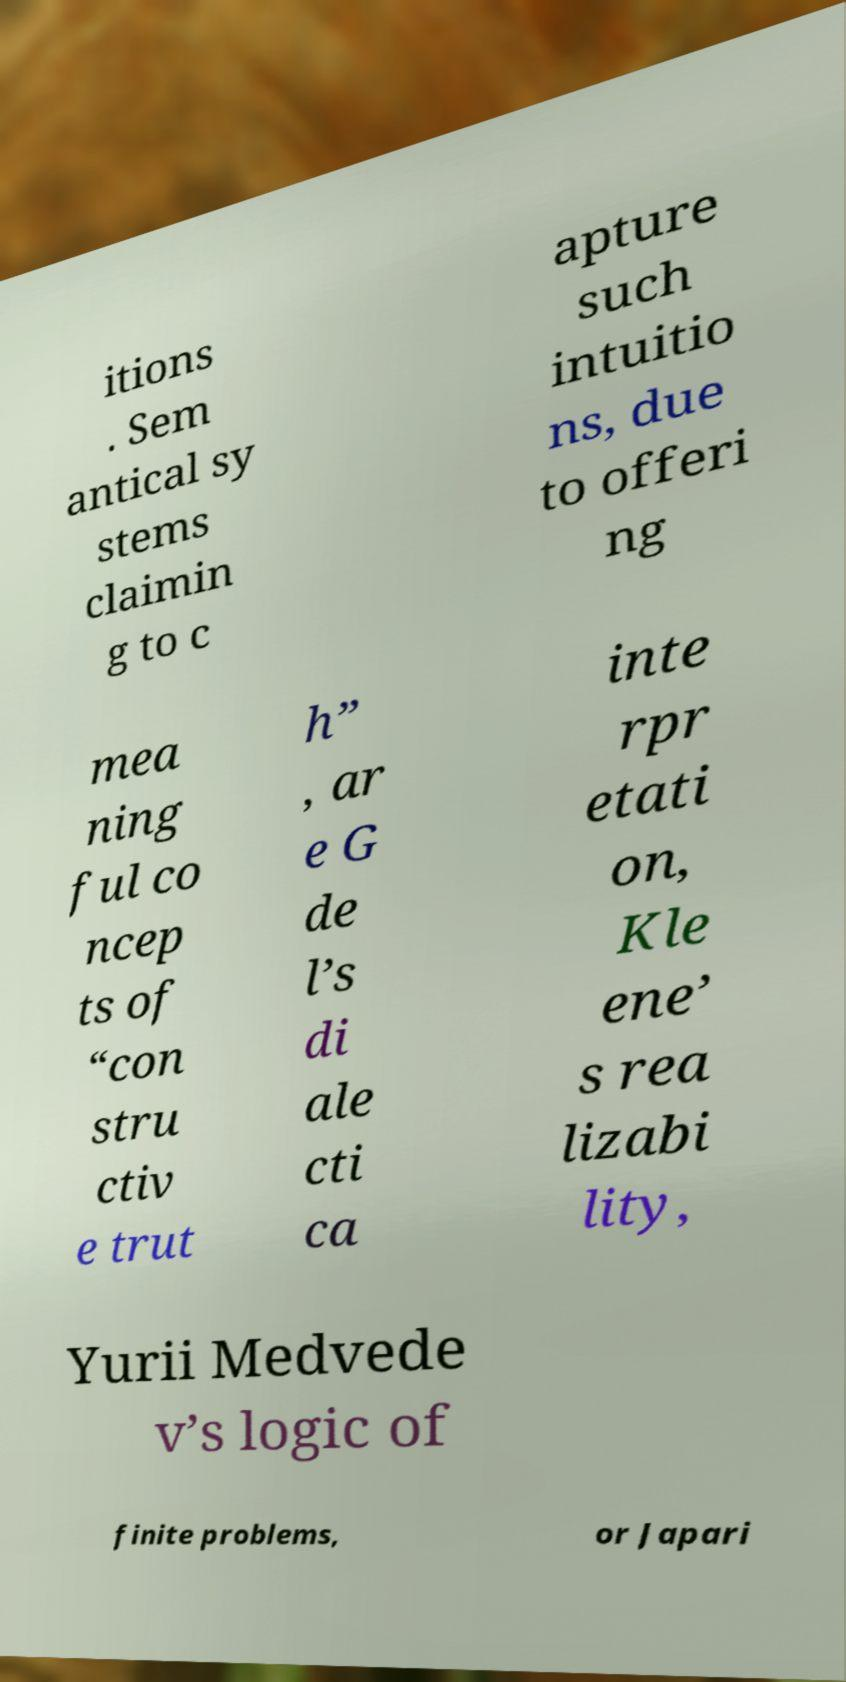Please read and relay the text visible in this image. What does it say? itions . Sem antical sy stems claimin g to c apture such intuitio ns, due to offeri ng mea ning ful co ncep ts of “con stru ctiv e trut h” , ar e G de l’s di ale cti ca inte rpr etati on, Kle ene’ s rea lizabi lity, Yurii Medvede v’s logic of finite problems, or Japari 